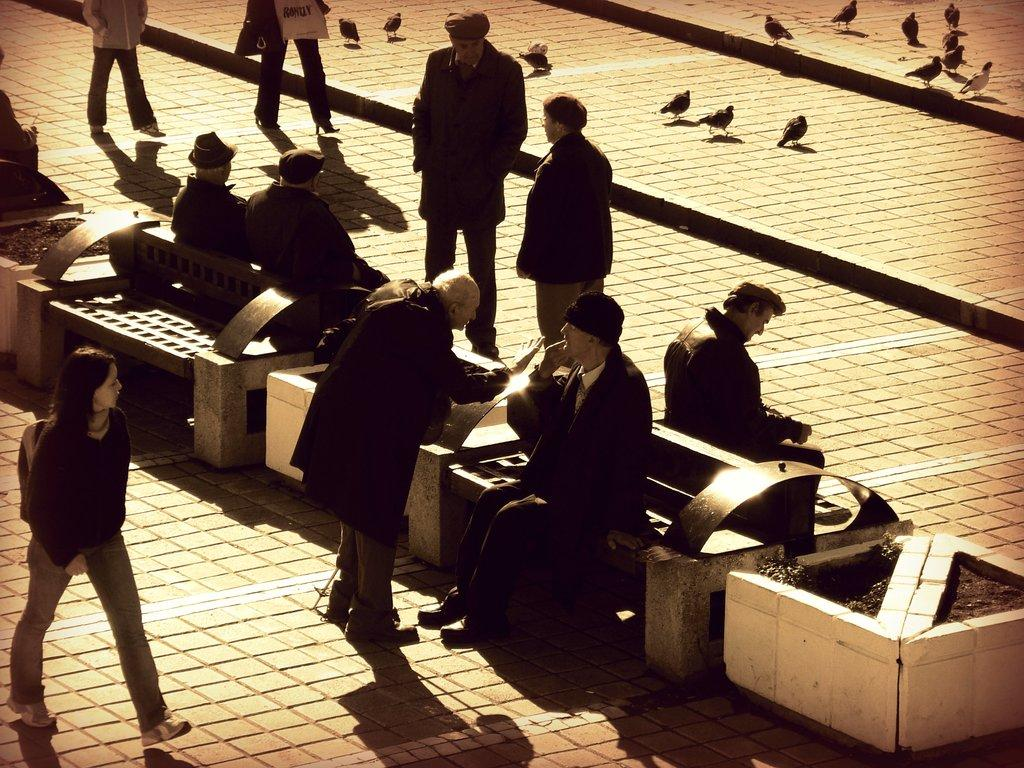What are the people in the image doing? There are people sitting on a bench and people walking on a road in the image. Can you describe the background of the image? In the background, there are many pigeons on the road. What type of organization is responsible for the jar floating in space in the image? There is no jar floating in space in the image; it only features people sitting on a bench, people walking on a road, and pigeons in the background. 